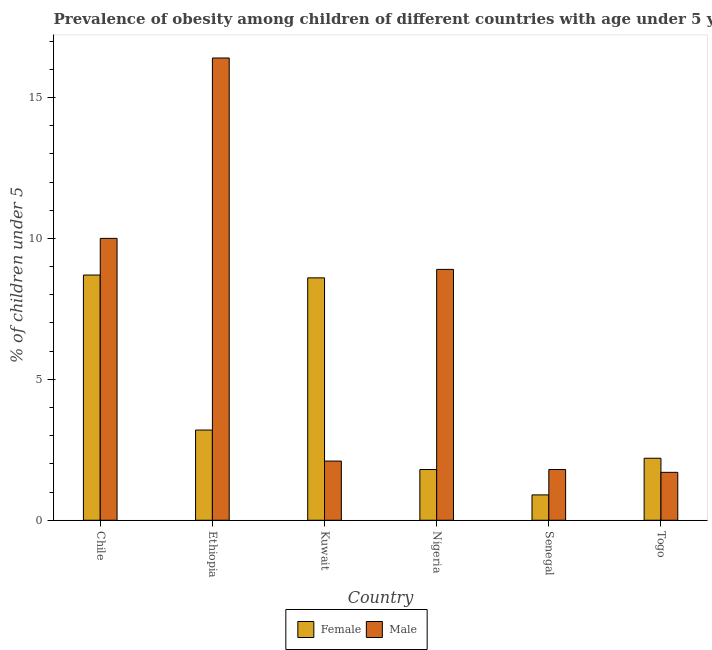How many different coloured bars are there?
Your response must be concise. 2. How many groups of bars are there?
Your response must be concise. 6. Are the number of bars per tick equal to the number of legend labels?
Keep it short and to the point. Yes. How many bars are there on the 6th tick from the left?
Give a very brief answer. 2. What is the label of the 2nd group of bars from the left?
Your answer should be very brief. Ethiopia. What is the percentage of obese female children in Nigeria?
Provide a short and direct response. 1.8. Across all countries, what is the maximum percentage of obese female children?
Provide a short and direct response. 8.7. Across all countries, what is the minimum percentage of obese female children?
Make the answer very short. 0.9. In which country was the percentage of obese female children maximum?
Make the answer very short. Chile. In which country was the percentage of obese female children minimum?
Ensure brevity in your answer.  Senegal. What is the total percentage of obese male children in the graph?
Provide a succinct answer. 40.9. What is the difference between the percentage of obese male children in Ethiopia and that in Togo?
Give a very brief answer. 14.7. What is the difference between the percentage of obese male children in Togo and the percentage of obese female children in Kuwait?
Your response must be concise. -6.9. What is the average percentage of obese female children per country?
Ensure brevity in your answer.  4.23. What is the difference between the percentage of obese male children and percentage of obese female children in Kuwait?
Offer a very short reply. -6.5. What is the ratio of the percentage of obese male children in Chile to that in Ethiopia?
Provide a short and direct response. 0.61. Is the difference between the percentage of obese male children in Ethiopia and Nigeria greater than the difference between the percentage of obese female children in Ethiopia and Nigeria?
Ensure brevity in your answer.  Yes. What is the difference between the highest and the second highest percentage of obese female children?
Make the answer very short. 0.1. What is the difference between the highest and the lowest percentage of obese female children?
Offer a terse response. 7.8. In how many countries, is the percentage of obese male children greater than the average percentage of obese male children taken over all countries?
Provide a succinct answer. 3. Are all the bars in the graph horizontal?
Offer a terse response. No. How many countries are there in the graph?
Give a very brief answer. 6. What is the difference between two consecutive major ticks on the Y-axis?
Provide a succinct answer. 5. Where does the legend appear in the graph?
Make the answer very short. Bottom center. What is the title of the graph?
Offer a terse response. Prevalence of obesity among children of different countries with age under 5 years. What is the label or title of the Y-axis?
Ensure brevity in your answer.   % of children under 5. What is the  % of children under 5 in Female in Chile?
Offer a terse response. 8.7. What is the  % of children under 5 in Male in Chile?
Provide a succinct answer. 10. What is the  % of children under 5 of Female in Ethiopia?
Keep it short and to the point. 3.2. What is the  % of children under 5 in Male in Ethiopia?
Your answer should be compact. 16.4. What is the  % of children under 5 in Female in Kuwait?
Your answer should be compact. 8.6. What is the  % of children under 5 in Male in Kuwait?
Offer a terse response. 2.1. What is the  % of children under 5 of Female in Nigeria?
Your response must be concise. 1.8. What is the  % of children under 5 of Male in Nigeria?
Your answer should be compact. 8.9. What is the  % of children under 5 in Female in Senegal?
Your answer should be very brief. 0.9. What is the  % of children under 5 in Male in Senegal?
Give a very brief answer. 1.8. What is the  % of children under 5 in Female in Togo?
Keep it short and to the point. 2.2. What is the  % of children under 5 in Male in Togo?
Ensure brevity in your answer.  1.7. Across all countries, what is the maximum  % of children under 5 in Female?
Your answer should be very brief. 8.7. Across all countries, what is the maximum  % of children under 5 of Male?
Keep it short and to the point. 16.4. Across all countries, what is the minimum  % of children under 5 of Female?
Offer a very short reply. 0.9. Across all countries, what is the minimum  % of children under 5 in Male?
Provide a succinct answer. 1.7. What is the total  % of children under 5 of Female in the graph?
Keep it short and to the point. 25.4. What is the total  % of children under 5 of Male in the graph?
Make the answer very short. 40.9. What is the difference between the  % of children under 5 of Male in Chile and that in Ethiopia?
Give a very brief answer. -6.4. What is the difference between the  % of children under 5 in Male in Chile and that in Kuwait?
Give a very brief answer. 7.9. What is the difference between the  % of children under 5 in Male in Chile and that in Senegal?
Provide a short and direct response. 8.2. What is the difference between the  % of children under 5 of Female in Ethiopia and that in Kuwait?
Keep it short and to the point. -5.4. What is the difference between the  % of children under 5 of Female in Ethiopia and that in Nigeria?
Offer a terse response. 1.4. What is the difference between the  % of children under 5 of Male in Ethiopia and that in Nigeria?
Ensure brevity in your answer.  7.5. What is the difference between the  % of children under 5 of Male in Ethiopia and that in Senegal?
Offer a terse response. 14.6. What is the difference between the  % of children under 5 of Male in Kuwait and that in Nigeria?
Offer a terse response. -6.8. What is the difference between the  % of children under 5 of Female in Kuwait and that in Senegal?
Provide a succinct answer. 7.7. What is the difference between the  % of children under 5 in Male in Nigeria and that in Togo?
Your response must be concise. 7.2. What is the difference between the  % of children under 5 of Female in Chile and the  % of children under 5 of Male in Kuwait?
Give a very brief answer. 6.6. What is the difference between the  % of children under 5 in Female in Chile and the  % of children under 5 in Male in Nigeria?
Your response must be concise. -0.2. What is the difference between the  % of children under 5 of Female in Chile and the  % of children under 5 of Male in Senegal?
Offer a terse response. 6.9. What is the difference between the  % of children under 5 of Female in Kuwait and the  % of children under 5 of Male in Senegal?
Keep it short and to the point. 6.8. What is the difference between the  % of children under 5 in Female in Nigeria and the  % of children under 5 in Male in Senegal?
Make the answer very short. 0. What is the average  % of children under 5 of Female per country?
Keep it short and to the point. 4.23. What is the average  % of children under 5 of Male per country?
Your answer should be very brief. 6.82. What is the difference between the  % of children under 5 in Female and  % of children under 5 in Male in Chile?
Give a very brief answer. -1.3. What is the difference between the  % of children under 5 in Female and  % of children under 5 in Male in Ethiopia?
Keep it short and to the point. -13.2. What is the difference between the  % of children under 5 of Female and  % of children under 5 of Male in Kuwait?
Your answer should be very brief. 6.5. What is the difference between the  % of children under 5 in Female and  % of children under 5 in Male in Senegal?
Offer a very short reply. -0.9. What is the ratio of the  % of children under 5 in Female in Chile to that in Ethiopia?
Offer a terse response. 2.72. What is the ratio of the  % of children under 5 of Male in Chile to that in Ethiopia?
Ensure brevity in your answer.  0.61. What is the ratio of the  % of children under 5 in Female in Chile to that in Kuwait?
Your answer should be compact. 1.01. What is the ratio of the  % of children under 5 in Male in Chile to that in Kuwait?
Keep it short and to the point. 4.76. What is the ratio of the  % of children under 5 in Female in Chile to that in Nigeria?
Keep it short and to the point. 4.83. What is the ratio of the  % of children under 5 of Male in Chile to that in Nigeria?
Give a very brief answer. 1.12. What is the ratio of the  % of children under 5 in Female in Chile to that in Senegal?
Your answer should be very brief. 9.67. What is the ratio of the  % of children under 5 of Male in Chile to that in Senegal?
Your answer should be very brief. 5.56. What is the ratio of the  % of children under 5 in Female in Chile to that in Togo?
Give a very brief answer. 3.95. What is the ratio of the  % of children under 5 of Male in Chile to that in Togo?
Make the answer very short. 5.88. What is the ratio of the  % of children under 5 of Female in Ethiopia to that in Kuwait?
Provide a short and direct response. 0.37. What is the ratio of the  % of children under 5 in Male in Ethiopia to that in Kuwait?
Your answer should be compact. 7.81. What is the ratio of the  % of children under 5 of Female in Ethiopia to that in Nigeria?
Provide a short and direct response. 1.78. What is the ratio of the  % of children under 5 of Male in Ethiopia to that in Nigeria?
Provide a short and direct response. 1.84. What is the ratio of the  % of children under 5 of Female in Ethiopia to that in Senegal?
Provide a succinct answer. 3.56. What is the ratio of the  % of children under 5 of Male in Ethiopia to that in Senegal?
Ensure brevity in your answer.  9.11. What is the ratio of the  % of children under 5 in Female in Ethiopia to that in Togo?
Offer a very short reply. 1.45. What is the ratio of the  % of children under 5 of Male in Ethiopia to that in Togo?
Your answer should be very brief. 9.65. What is the ratio of the  % of children under 5 in Female in Kuwait to that in Nigeria?
Ensure brevity in your answer.  4.78. What is the ratio of the  % of children under 5 in Male in Kuwait to that in Nigeria?
Keep it short and to the point. 0.24. What is the ratio of the  % of children under 5 of Female in Kuwait to that in Senegal?
Provide a short and direct response. 9.56. What is the ratio of the  % of children under 5 of Male in Kuwait to that in Senegal?
Offer a terse response. 1.17. What is the ratio of the  % of children under 5 in Female in Kuwait to that in Togo?
Provide a short and direct response. 3.91. What is the ratio of the  % of children under 5 of Male in Kuwait to that in Togo?
Ensure brevity in your answer.  1.24. What is the ratio of the  % of children under 5 of Female in Nigeria to that in Senegal?
Ensure brevity in your answer.  2. What is the ratio of the  % of children under 5 in Male in Nigeria to that in Senegal?
Ensure brevity in your answer.  4.94. What is the ratio of the  % of children under 5 of Female in Nigeria to that in Togo?
Provide a short and direct response. 0.82. What is the ratio of the  % of children under 5 in Male in Nigeria to that in Togo?
Offer a very short reply. 5.24. What is the ratio of the  % of children under 5 in Female in Senegal to that in Togo?
Your answer should be very brief. 0.41. What is the ratio of the  % of children under 5 of Male in Senegal to that in Togo?
Give a very brief answer. 1.06. What is the difference between the highest and the lowest  % of children under 5 in Female?
Keep it short and to the point. 7.8. 